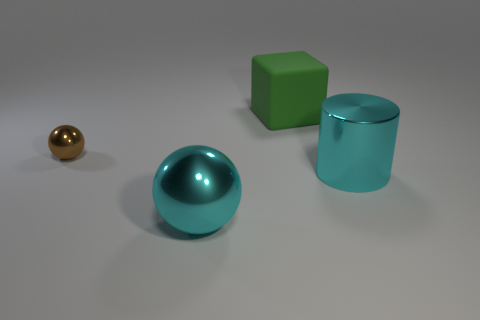Is the size of the object that is on the left side of the large ball the same as the cyan object in front of the large shiny cylinder?
Offer a very short reply. No. How many other objects are there of the same size as the brown metallic ball?
Give a very brief answer. 0. What material is the cyan object that is on the left side of the large cyan object that is behind the ball right of the tiny brown sphere?
Keep it short and to the point. Metal. There is a green cube; does it have the same size as the shiny object on the right side of the green object?
Provide a succinct answer. Yes. There is a metal thing that is on the left side of the large cylinder and on the right side of the small shiny thing; how big is it?
Give a very brief answer. Large. Is there a thing of the same color as the rubber block?
Your answer should be compact. No. There is a metallic object that is in front of the cyan shiny thing to the right of the big metallic ball; what color is it?
Offer a very short reply. Cyan. Is the number of tiny metallic things that are behind the large cube less than the number of big things that are to the left of the cylinder?
Ensure brevity in your answer.  Yes. Does the cyan ball have the same size as the block?
Offer a very short reply. Yes. The thing that is both on the left side of the big cube and on the right side of the tiny metal object has what shape?
Offer a terse response. Sphere. 